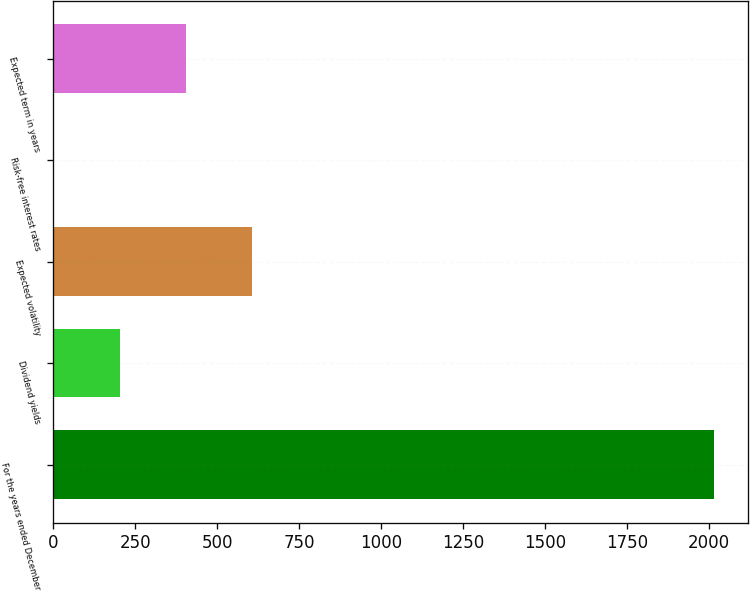<chart> <loc_0><loc_0><loc_500><loc_500><bar_chart><fcel>For the years ended December<fcel>Dividend yields<fcel>Expected volatility<fcel>Risk-free interest rates<fcel>Expected term in years<nl><fcel>2017<fcel>203.68<fcel>606.64<fcel>2.2<fcel>405.16<nl></chart> 